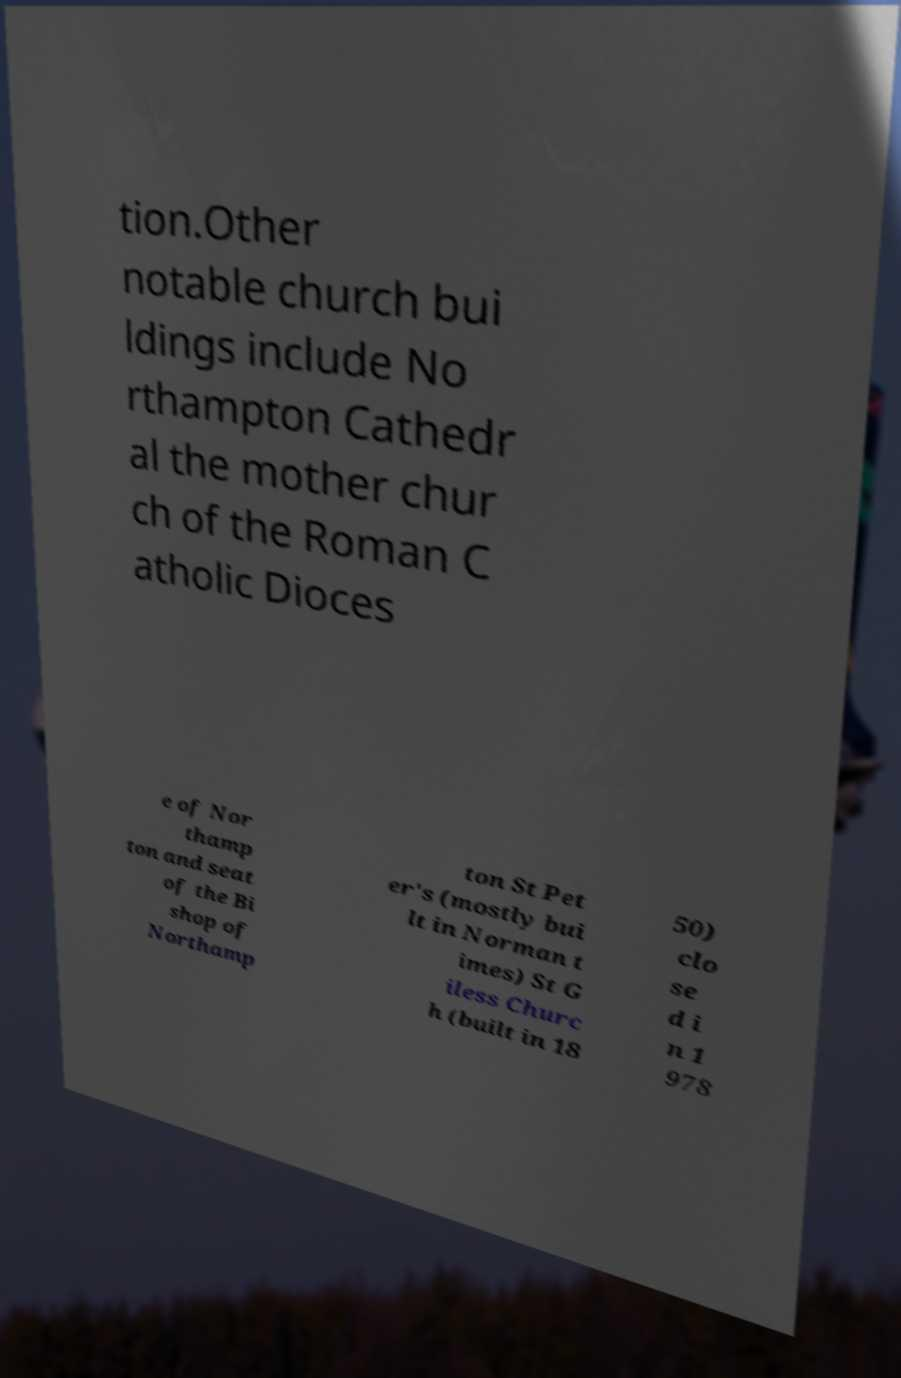Can you read and provide the text displayed in the image?This photo seems to have some interesting text. Can you extract and type it out for me? tion.Other notable church bui ldings include No rthampton Cathedr al the mother chur ch of the Roman C atholic Dioces e of Nor thamp ton and seat of the Bi shop of Northamp ton St Pet er's (mostly bui lt in Norman t imes) St G iless Churc h (built in 18 50) clo se d i n 1 978 